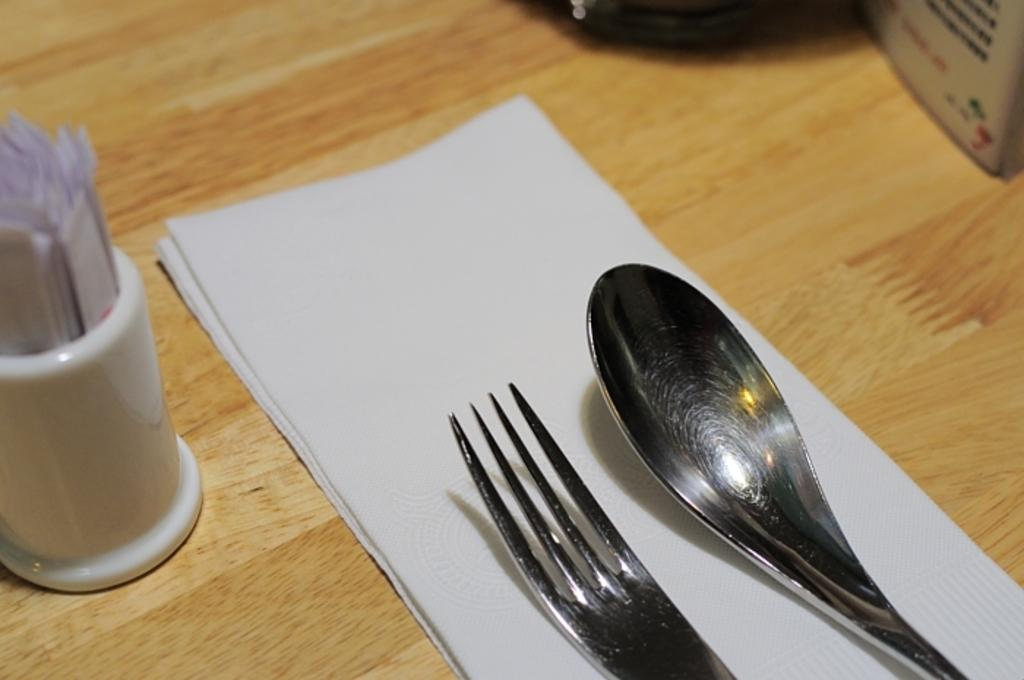What type of table is in the image? There is a wooden table in the image. What items can be seen on the table? There are tissues, a fork, a spoon, and a white color glass on the table. What is inside the glass on the table? There are papers in the glass. What type of skin is visible on the table in the image? There is no skin visible on the table in the image; it is a wooden table. 